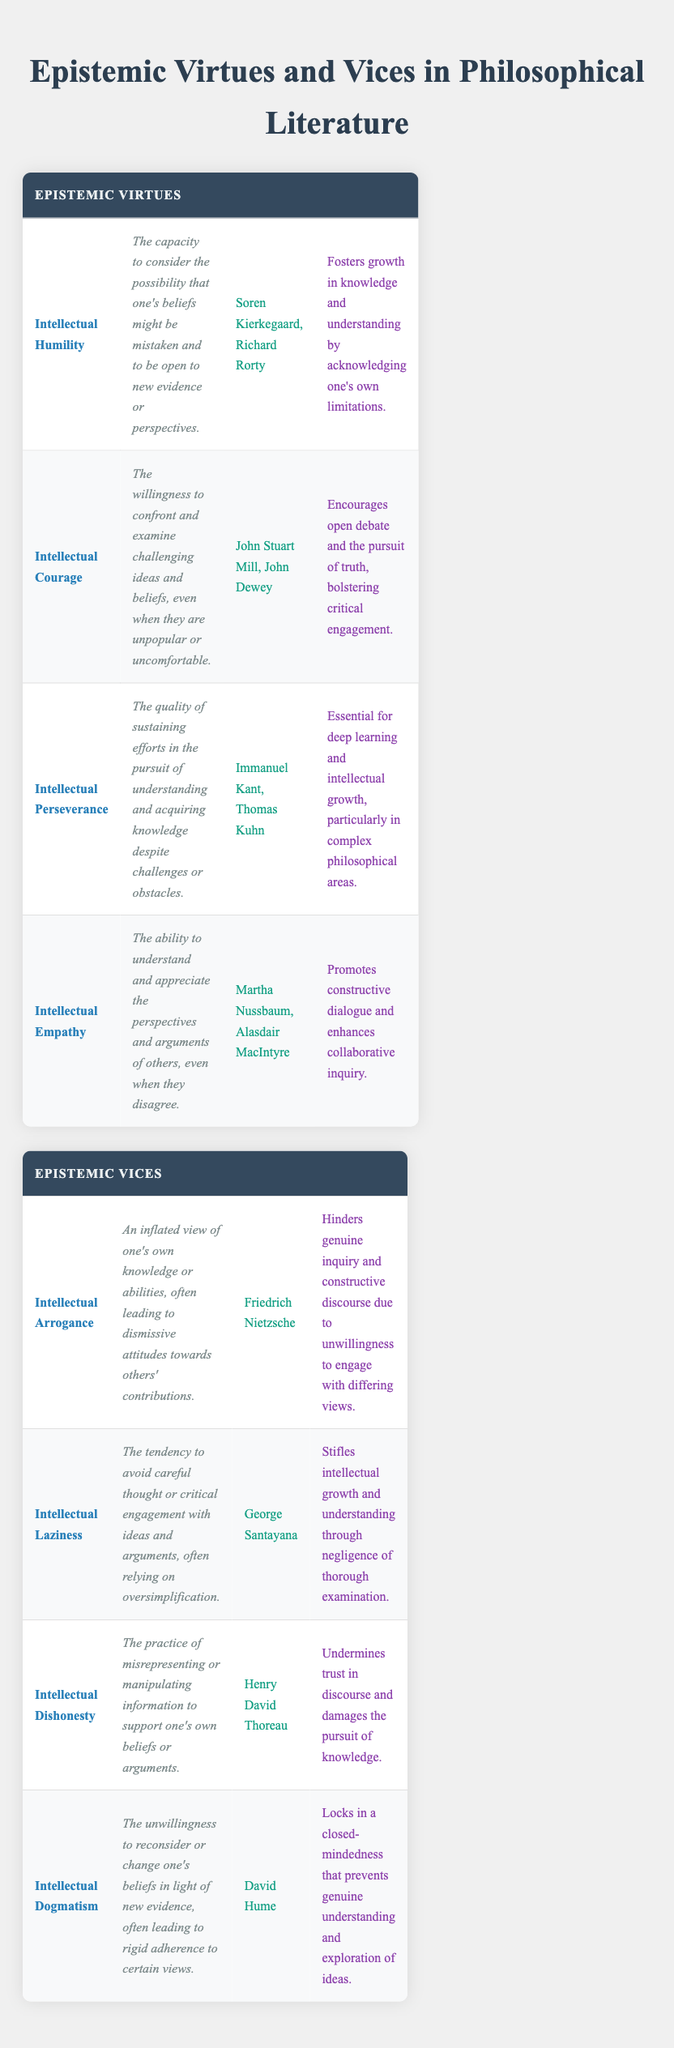What is the description of Intellectual Courage? From the table, the description of Intellectual Courage is "The willingness to confront and examine challenging ideas and beliefs, even when they are unpopular or uncomfortable."
Answer: The willingness to confront and examine challenging ideas and beliefs, even when they are unpopular or uncomfortable Which philosophers are associated with Intellectual Empathy? Referring to the table, the philosophers associated with Intellectual Empathy are Martha Nussbaum and Alasdair MacIntyre.
Answer: Martha Nussbaum, Alasdair MacIntyre Is Intellectual Dishonesty considered an epistemic vice? According to the table, Intellectual Dishonesty is listed as an epistemic vice, confirming that it is considered one.
Answer: Yes How many epistemic virtues are listed in the table? The table lists four distinct epistemic virtues: Intellectual Humility, Intellectual Courage, Intellectual Perseverance, and Intellectual Empathy. Therefore, the total is 4.
Answer: 4 Which epistemic vice corresponds to a reluctance to engage with differing perspectives? Intellectual Arrogance corresponds to an inflated view of one's own knowledge, often leading to dismissiveness towards others, which directly implies a reluctance to engage.
Answer: Intellectual Arrogance What is the relevance of Intellectual Laziness? The table states that Intellectual Laziness "Stifles intellectual growth and understanding through negligence of thorough examination," indicating its negative impact.
Answer: Stifles intellectual growth and understanding through negligence of thorough examination Which epistemic virtue is associated with Immanuel Kant? Looking at the entries, Intellectual Perseverance is associated with Immanuel Kant.
Answer: Intellectual Perseverance If you consider all the philosophers listed, how many total unique philosophers are mentioned across both virtues and vices? The unique philosophers mentioned are Soren Kierkegaard, Richard Rorty, John Stuart Mill, John Dewey, Immanuel Kant, Thomas Kuhn, Martha Nussbaum, Alasdair MacIntyre, Friedrich Nietzsche, George Santayana, Henry David Thoreau, and David Hume. Counting them gives us a total of 12 unique philosophers.
Answer: 12 What common theme do all the epistemic virtues share in terms of relevance? All epistemic virtues, as seen in the table, emphasize enhancing knowledge and understanding through personal engagement and openness to ideas and evidence.
Answer: Enhancing knowledge and understanding through personal engagement and openness to ideas and evidence 